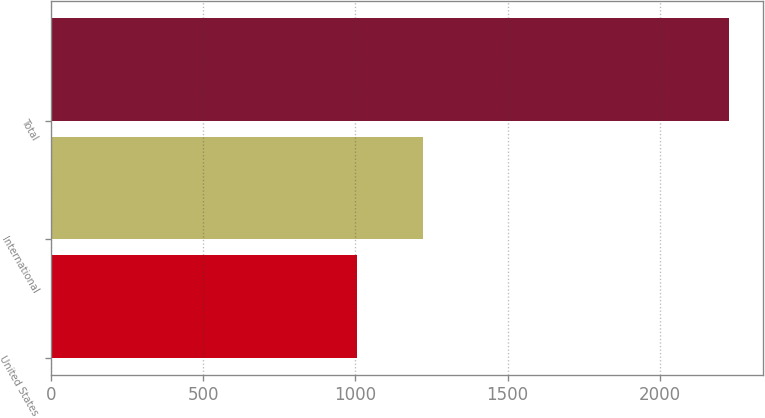Convert chart. <chart><loc_0><loc_0><loc_500><loc_500><bar_chart><fcel>United States<fcel>International<fcel>Total<nl><fcel>1006.3<fcel>1223.3<fcel>2229.6<nl></chart> 